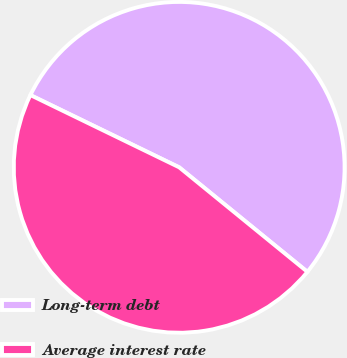Convert chart to OTSL. <chart><loc_0><loc_0><loc_500><loc_500><pie_chart><fcel>Long-term debt<fcel>Average interest rate<nl><fcel>53.69%<fcel>46.31%<nl></chart> 